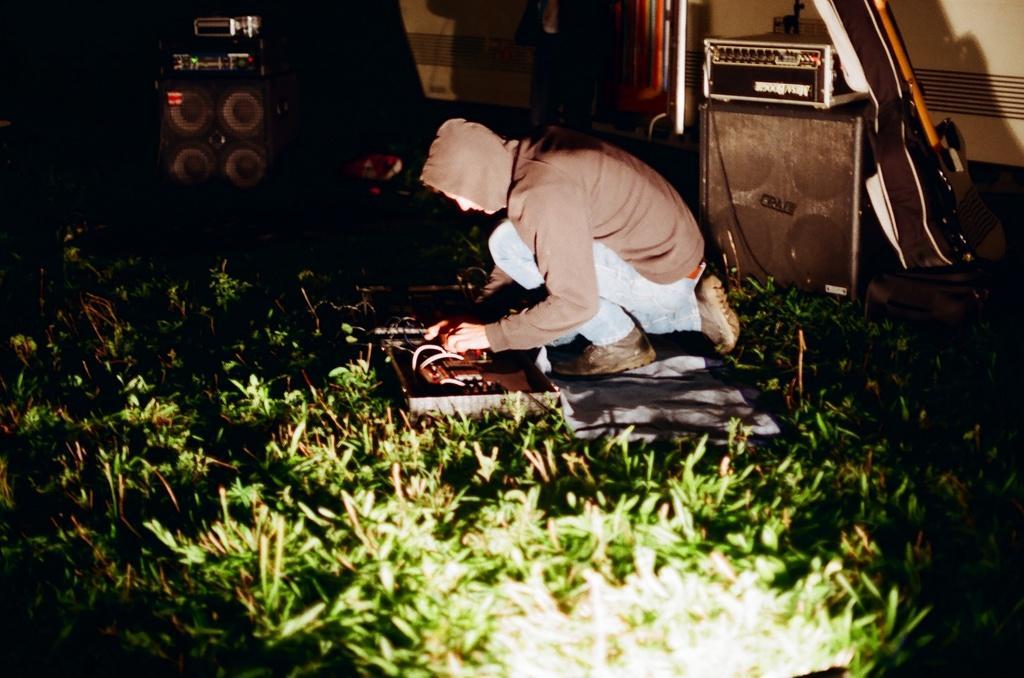Could you give a brief overview of what you see in this image? In this picture we can see a man on the grass, beside him we can find speakers, guitar and few musical instruments. 